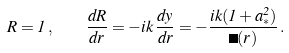<formula> <loc_0><loc_0><loc_500><loc_500>R = 1 \, , \quad \frac { d R } { d r } = - i k \, \frac { d y } { d r } = - \frac { i k ( 1 + a _ { * } ^ { 2 } ) } { \Delta ( r ) } \, .</formula> 